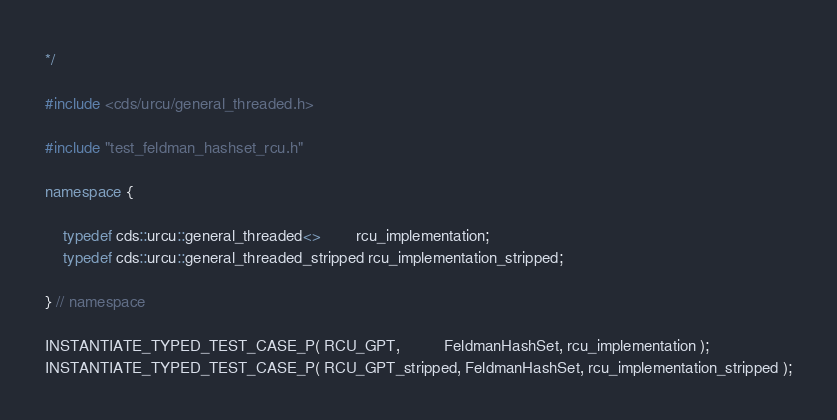<code> <loc_0><loc_0><loc_500><loc_500><_C++_>*/

#include <cds/urcu/general_threaded.h>

#include "test_feldman_hashset_rcu.h"

namespace {

    typedef cds::urcu::general_threaded<>        rcu_implementation;
    typedef cds::urcu::general_threaded_stripped rcu_implementation_stripped;

} // namespace

INSTANTIATE_TYPED_TEST_CASE_P( RCU_GPT,          FeldmanHashSet, rcu_implementation );
INSTANTIATE_TYPED_TEST_CASE_P( RCU_GPT_stripped, FeldmanHashSet, rcu_implementation_stripped );
</code> 